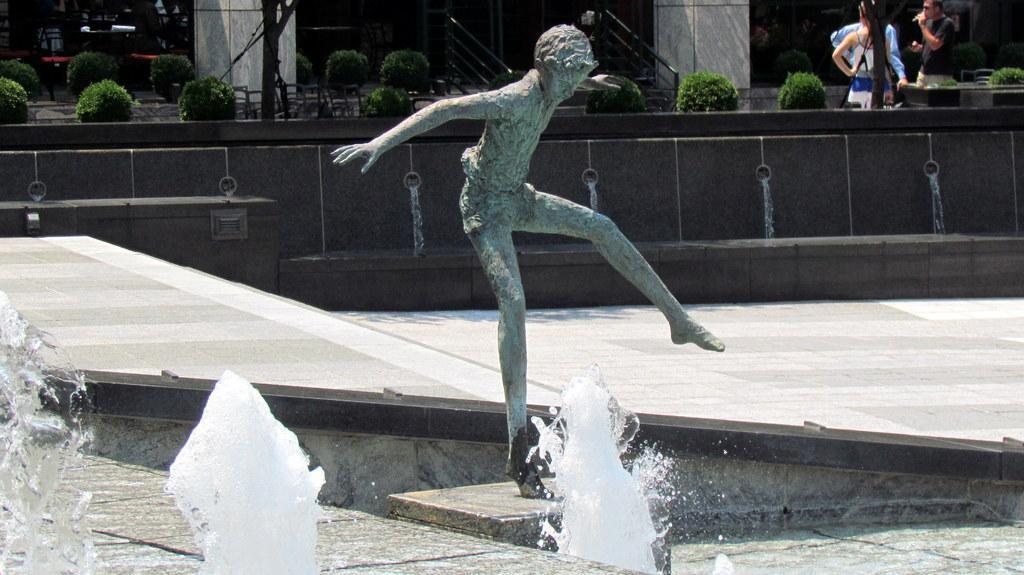Please provide a concise description of this image. In this image, I can see the sculpture of a person. I think these are the water fountains. At the top of the image, I can see the bushes. There are few people standing. In the background, that looks like a building with the pillars. I think this is a pathway. 